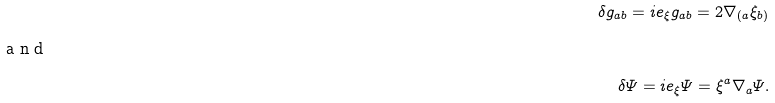<formula> <loc_0><loc_0><loc_500><loc_500>\delta g _ { a b } = \L i e _ { \xi } g _ { a b } = 2 \nabla _ { ( a } \xi _ { b ) } \\ \intertext { a n d } \delta \varPsi = \L i e _ { \xi } \varPsi = \xi ^ { a } \nabla _ { a } \varPsi .</formula> 